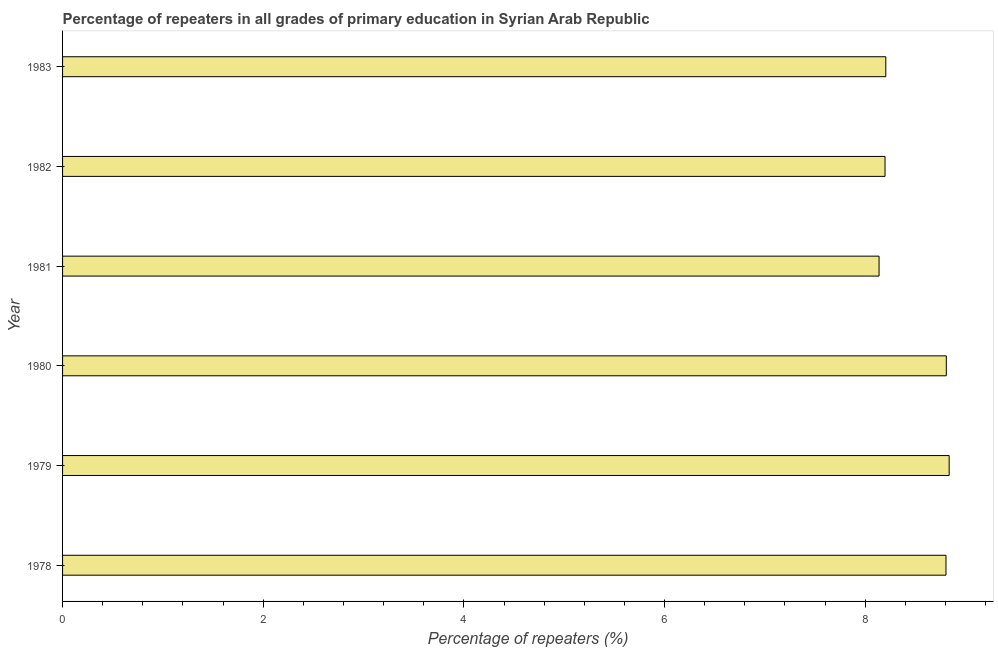Does the graph contain grids?
Offer a terse response. No. What is the title of the graph?
Offer a very short reply. Percentage of repeaters in all grades of primary education in Syrian Arab Republic. What is the label or title of the X-axis?
Offer a very short reply. Percentage of repeaters (%). What is the label or title of the Y-axis?
Provide a succinct answer. Year. What is the percentage of repeaters in primary education in 1981?
Provide a short and direct response. 8.14. Across all years, what is the maximum percentage of repeaters in primary education?
Make the answer very short. 8.84. Across all years, what is the minimum percentage of repeaters in primary education?
Your response must be concise. 8.14. In which year was the percentage of repeaters in primary education maximum?
Provide a short and direct response. 1979. In which year was the percentage of repeaters in primary education minimum?
Provide a succinct answer. 1981. What is the sum of the percentage of repeaters in primary education?
Provide a short and direct response. 50.99. What is the difference between the percentage of repeaters in primary education in 1979 and 1983?
Your answer should be very brief. 0.63. What is the average percentage of repeaters in primary education per year?
Your answer should be compact. 8.5. What is the median percentage of repeaters in primary education?
Your answer should be very brief. 8.51. What is the ratio of the percentage of repeaters in primary education in 1978 to that in 1981?
Your answer should be compact. 1.08. Is the difference between the percentage of repeaters in primary education in 1980 and 1983 greater than the difference between any two years?
Your answer should be compact. No. What is the difference between the highest and the second highest percentage of repeaters in primary education?
Offer a very short reply. 0.03. What is the difference between the highest and the lowest percentage of repeaters in primary education?
Offer a very short reply. 0.7. In how many years, is the percentage of repeaters in primary education greater than the average percentage of repeaters in primary education taken over all years?
Your answer should be very brief. 3. How many bars are there?
Your answer should be very brief. 6. Are all the bars in the graph horizontal?
Offer a terse response. Yes. How many years are there in the graph?
Make the answer very short. 6. What is the Percentage of repeaters (%) of 1978?
Make the answer very short. 8.81. What is the Percentage of repeaters (%) in 1979?
Make the answer very short. 8.84. What is the Percentage of repeaters (%) of 1980?
Keep it short and to the point. 8.81. What is the Percentage of repeaters (%) in 1981?
Make the answer very short. 8.14. What is the Percentage of repeaters (%) of 1982?
Your answer should be very brief. 8.2. What is the Percentage of repeaters (%) of 1983?
Make the answer very short. 8.21. What is the difference between the Percentage of repeaters (%) in 1978 and 1979?
Your answer should be compact. -0.03. What is the difference between the Percentage of repeaters (%) in 1978 and 1980?
Your response must be concise. -0. What is the difference between the Percentage of repeaters (%) in 1978 and 1981?
Provide a short and direct response. 0.67. What is the difference between the Percentage of repeaters (%) in 1978 and 1982?
Your answer should be compact. 0.61. What is the difference between the Percentage of repeaters (%) in 1978 and 1983?
Provide a short and direct response. 0.6. What is the difference between the Percentage of repeaters (%) in 1979 and 1980?
Your response must be concise. 0.03. What is the difference between the Percentage of repeaters (%) in 1979 and 1981?
Give a very brief answer. 0.7. What is the difference between the Percentage of repeaters (%) in 1979 and 1982?
Give a very brief answer. 0.64. What is the difference between the Percentage of repeaters (%) in 1979 and 1983?
Your response must be concise. 0.63. What is the difference between the Percentage of repeaters (%) in 1980 and 1981?
Offer a very short reply. 0.67. What is the difference between the Percentage of repeaters (%) in 1980 and 1982?
Offer a very short reply. 0.61. What is the difference between the Percentage of repeaters (%) in 1980 and 1983?
Provide a succinct answer. 0.6. What is the difference between the Percentage of repeaters (%) in 1981 and 1982?
Your answer should be compact. -0.06. What is the difference between the Percentage of repeaters (%) in 1981 and 1983?
Keep it short and to the point. -0.07. What is the difference between the Percentage of repeaters (%) in 1982 and 1983?
Ensure brevity in your answer.  -0.01. What is the ratio of the Percentage of repeaters (%) in 1978 to that in 1980?
Provide a succinct answer. 1. What is the ratio of the Percentage of repeaters (%) in 1978 to that in 1981?
Offer a terse response. 1.08. What is the ratio of the Percentage of repeaters (%) in 1978 to that in 1982?
Make the answer very short. 1.07. What is the ratio of the Percentage of repeaters (%) in 1978 to that in 1983?
Offer a terse response. 1.07. What is the ratio of the Percentage of repeaters (%) in 1979 to that in 1980?
Offer a very short reply. 1. What is the ratio of the Percentage of repeaters (%) in 1979 to that in 1981?
Ensure brevity in your answer.  1.09. What is the ratio of the Percentage of repeaters (%) in 1979 to that in 1982?
Your answer should be very brief. 1.08. What is the ratio of the Percentage of repeaters (%) in 1979 to that in 1983?
Give a very brief answer. 1.08. What is the ratio of the Percentage of repeaters (%) in 1980 to that in 1981?
Provide a short and direct response. 1.08. What is the ratio of the Percentage of repeaters (%) in 1980 to that in 1982?
Keep it short and to the point. 1.07. What is the ratio of the Percentage of repeaters (%) in 1980 to that in 1983?
Ensure brevity in your answer.  1.07. What is the ratio of the Percentage of repeaters (%) in 1981 to that in 1983?
Ensure brevity in your answer.  0.99. 